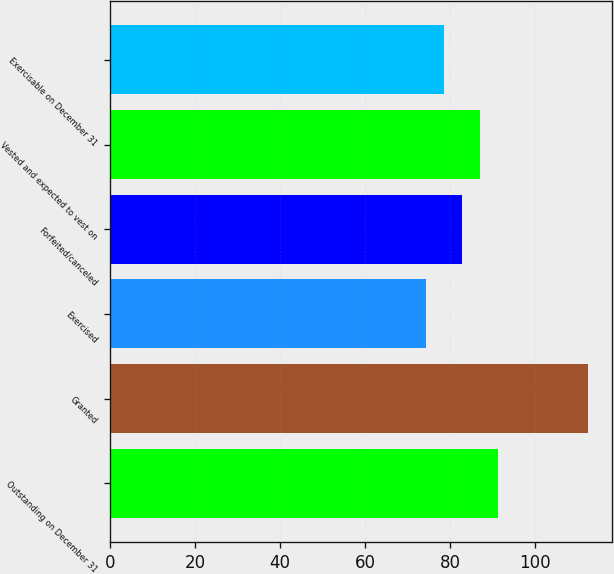Convert chart. <chart><loc_0><loc_0><loc_500><loc_500><bar_chart><fcel>Outstanding on December 31<fcel>Granted<fcel>Exercised<fcel>Forfeited/canceled<fcel>Vested and expected to vest on<fcel>Exercisable on December 31<nl><fcel>91.19<fcel>112.43<fcel>74.23<fcel>82.71<fcel>86.95<fcel>78.47<nl></chart> 